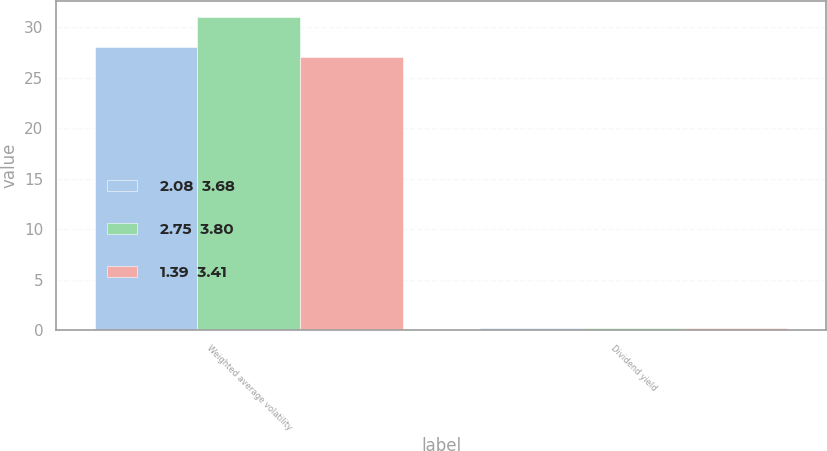<chart> <loc_0><loc_0><loc_500><loc_500><stacked_bar_chart><ecel><fcel>Weighted average volatility<fcel>Dividend yield<nl><fcel>2.08  3.68<fcel>28<fcel>0.2<nl><fcel>2.75  3.80<fcel>31<fcel>0.2<nl><fcel>1.39  3.41<fcel>27<fcel>0.2<nl></chart> 